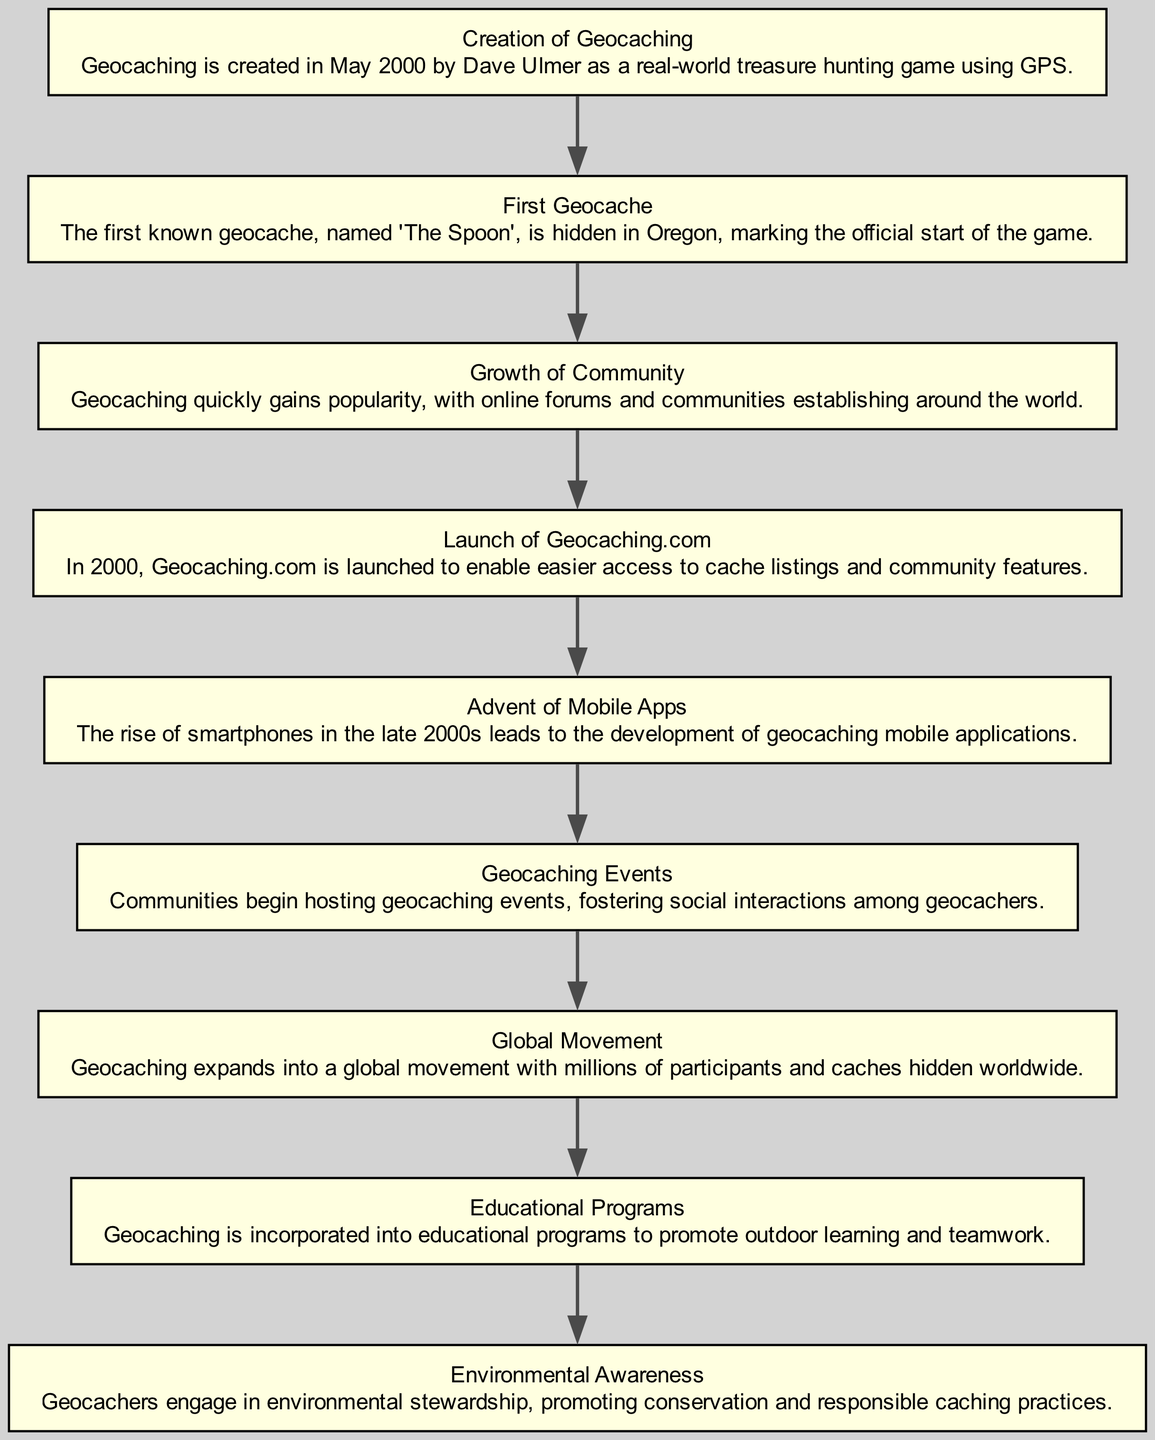What is the first element in the diagram? The first element in the diagram is "Creation of Geocaching," which describes its origin in May 2000 by Dave Ulmer.
Answer: Creation of Geocaching How many primary events are depicted in the flow chart? There are nine primary events represented in the flow chart, each corresponding to a significant milestone in the history of geocaching.
Answer: 9 Which element follows the creation of geocaching? The element that follows the creation of geocaching is "First Geocache," which details the hiding of the first cache in Oregon.
Answer: First Geocache What type of development occurred in the late 2000s? The late 2000s saw the advent of mobile apps for geocaching, enhancing the accessibility and enjoyment of the game.
Answer: Advent of Mobile Apps What are geocaching events primarily known for? Geocaching events are known for fostering social interactions among geocachers, creating a community feel within the game.
Answer: Social interactions Which step emphasizes environmental responsibility? The step that emphasizes environmental responsibility is "Environmental Awareness," highlighting geocachers' engagement in conservation.
Answer: Environmental Awareness What milestone was reached when geocaching expanded globally? The milestone reached when geocaching expanded globally is labeled as "Global Movement," indicating millions of participants and caches worldwide.
Answer: Global Movement Which element contributes to outdoor learning and teamwork? The element that contributes to outdoor learning and teamwork is "Educational Programs," as it incorporates geocaching into educational activities.
Answer: Educational Programs What online platform was launched to enhance geocaching access? The online platform launched to enhance geocaching access is "Launch of Geocaching.com," which provided listings and community features.
Answer: Launch of Geocaching.com 